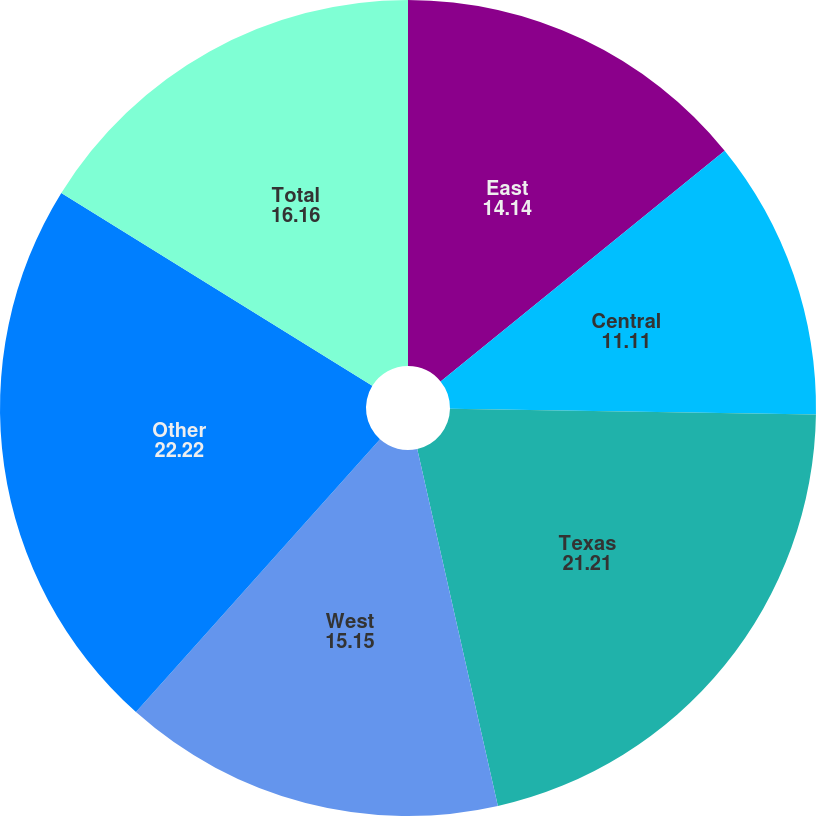Convert chart. <chart><loc_0><loc_0><loc_500><loc_500><pie_chart><fcel>East<fcel>Central<fcel>Texas<fcel>West<fcel>Other<fcel>Total<nl><fcel>14.14%<fcel>11.11%<fcel>21.21%<fcel>15.15%<fcel>22.22%<fcel>16.16%<nl></chart> 